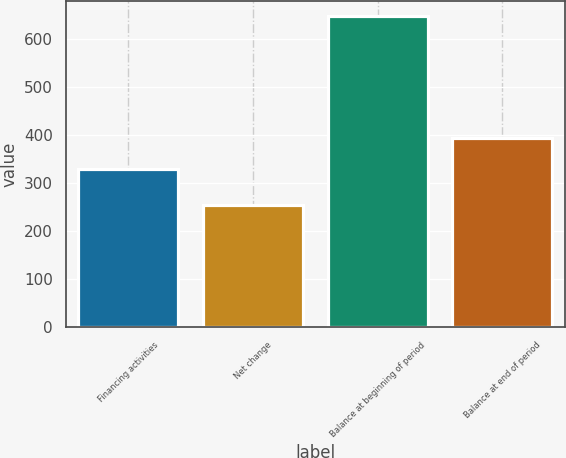Convert chart to OTSL. <chart><loc_0><loc_0><loc_500><loc_500><bar_chart><fcel>Financing activities<fcel>Net change<fcel>Balance at beginning of period<fcel>Balance at end of period<nl><fcel>330<fcel>254<fcel>648<fcel>394<nl></chart> 